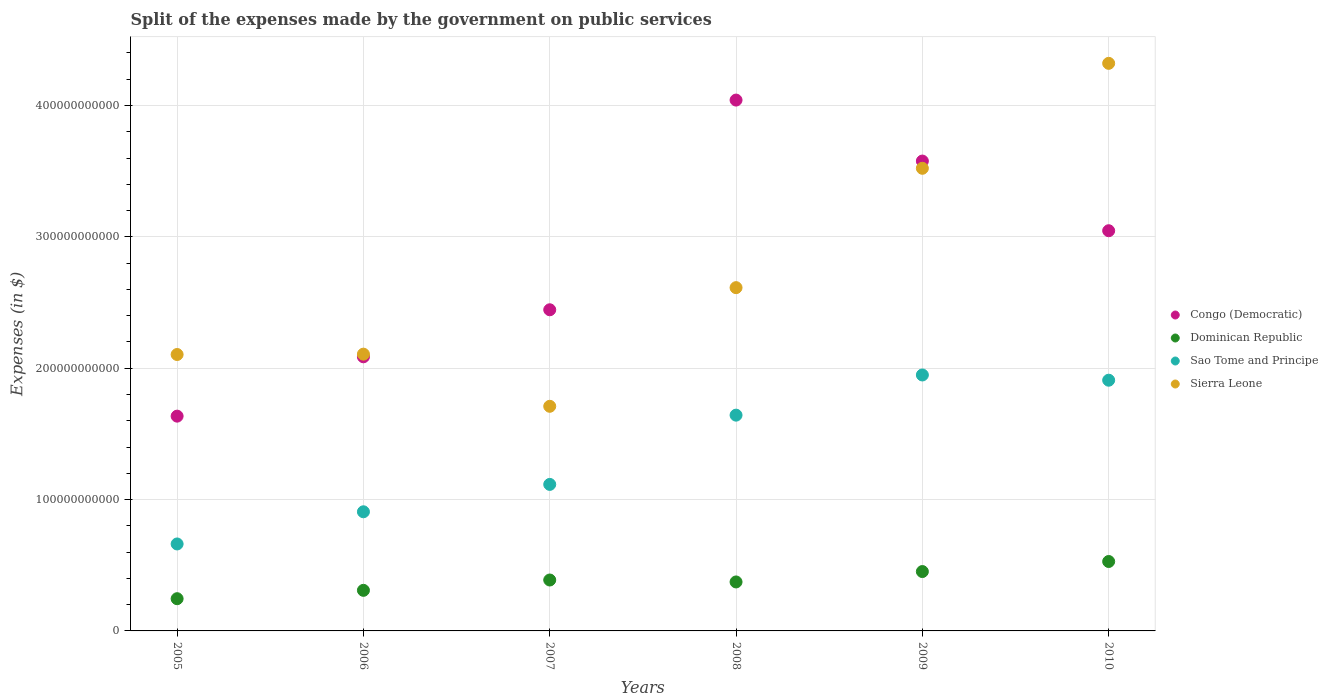How many different coloured dotlines are there?
Your answer should be very brief. 4. Is the number of dotlines equal to the number of legend labels?
Offer a terse response. Yes. What is the expenses made by the government on public services in Congo (Democratic) in 2008?
Provide a succinct answer. 4.04e+11. Across all years, what is the maximum expenses made by the government on public services in Sierra Leone?
Offer a terse response. 4.32e+11. Across all years, what is the minimum expenses made by the government on public services in Congo (Democratic)?
Offer a terse response. 1.64e+11. In which year was the expenses made by the government on public services in Dominican Republic minimum?
Make the answer very short. 2005. What is the total expenses made by the government on public services in Congo (Democratic) in the graph?
Provide a succinct answer. 1.68e+12. What is the difference between the expenses made by the government on public services in Sierra Leone in 2007 and that in 2010?
Provide a short and direct response. -2.61e+11. What is the difference between the expenses made by the government on public services in Sierra Leone in 2006 and the expenses made by the government on public services in Dominican Republic in 2007?
Your response must be concise. 1.72e+11. What is the average expenses made by the government on public services in Congo (Democratic) per year?
Your answer should be compact. 2.81e+11. In the year 2006, what is the difference between the expenses made by the government on public services in Sierra Leone and expenses made by the government on public services in Sao Tome and Principe?
Your response must be concise. 1.20e+11. In how many years, is the expenses made by the government on public services in Congo (Democratic) greater than 100000000000 $?
Provide a short and direct response. 6. What is the ratio of the expenses made by the government on public services in Dominican Republic in 2008 to that in 2009?
Provide a succinct answer. 0.82. Is the expenses made by the government on public services in Dominican Republic in 2008 less than that in 2010?
Give a very brief answer. Yes. Is the difference between the expenses made by the government on public services in Sierra Leone in 2005 and 2010 greater than the difference between the expenses made by the government on public services in Sao Tome and Principe in 2005 and 2010?
Keep it short and to the point. No. What is the difference between the highest and the second highest expenses made by the government on public services in Sao Tome and Principe?
Your answer should be compact. 3.98e+09. What is the difference between the highest and the lowest expenses made by the government on public services in Sao Tome and Principe?
Provide a short and direct response. 1.29e+11. Is the sum of the expenses made by the government on public services in Sao Tome and Principe in 2007 and 2008 greater than the maximum expenses made by the government on public services in Sierra Leone across all years?
Your response must be concise. No. Is it the case that in every year, the sum of the expenses made by the government on public services in Sao Tome and Principe and expenses made by the government on public services in Dominican Republic  is greater than the expenses made by the government on public services in Congo (Democratic)?
Your answer should be very brief. No. Is the expenses made by the government on public services in Sao Tome and Principe strictly greater than the expenses made by the government on public services in Dominican Republic over the years?
Your answer should be compact. Yes. How many years are there in the graph?
Your answer should be very brief. 6. What is the difference between two consecutive major ticks on the Y-axis?
Your response must be concise. 1.00e+11. Are the values on the major ticks of Y-axis written in scientific E-notation?
Offer a terse response. No. Does the graph contain any zero values?
Your answer should be compact. No. Does the graph contain grids?
Provide a short and direct response. Yes. What is the title of the graph?
Make the answer very short. Split of the expenses made by the government on public services. What is the label or title of the Y-axis?
Your response must be concise. Expenses (in $). What is the Expenses (in $) in Congo (Democratic) in 2005?
Offer a terse response. 1.64e+11. What is the Expenses (in $) in Dominican Republic in 2005?
Provide a short and direct response. 2.45e+1. What is the Expenses (in $) of Sao Tome and Principe in 2005?
Provide a short and direct response. 6.62e+1. What is the Expenses (in $) in Sierra Leone in 2005?
Your response must be concise. 2.10e+11. What is the Expenses (in $) in Congo (Democratic) in 2006?
Give a very brief answer. 2.09e+11. What is the Expenses (in $) in Dominican Republic in 2006?
Offer a very short reply. 3.09e+1. What is the Expenses (in $) of Sao Tome and Principe in 2006?
Offer a terse response. 9.07e+1. What is the Expenses (in $) in Sierra Leone in 2006?
Keep it short and to the point. 2.11e+11. What is the Expenses (in $) in Congo (Democratic) in 2007?
Ensure brevity in your answer.  2.44e+11. What is the Expenses (in $) in Dominican Republic in 2007?
Ensure brevity in your answer.  3.88e+1. What is the Expenses (in $) of Sao Tome and Principe in 2007?
Keep it short and to the point. 1.12e+11. What is the Expenses (in $) in Sierra Leone in 2007?
Offer a terse response. 1.71e+11. What is the Expenses (in $) of Congo (Democratic) in 2008?
Make the answer very short. 4.04e+11. What is the Expenses (in $) of Dominican Republic in 2008?
Give a very brief answer. 3.73e+1. What is the Expenses (in $) in Sao Tome and Principe in 2008?
Give a very brief answer. 1.64e+11. What is the Expenses (in $) of Sierra Leone in 2008?
Offer a terse response. 2.61e+11. What is the Expenses (in $) of Congo (Democratic) in 2009?
Offer a terse response. 3.58e+11. What is the Expenses (in $) in Dominican Republic in 2009?
Provide a succinct answer. 4.52e+1. What is the Expenses (in $) in Sao Tome and Principe in 2009?
Your response must be concise. 1.95e+11. What is the Expenses (in $) in Sierra Leone in 2009?
Your answer should be very brief. 3.52e+11. What is the Expenses (in $) of Congo (Democratic) in 2010?
Make the answer very short. 3.05e+11. What is the Expenses (in $) in Dominican Republic in 2010?
Ensure brevity in your answer.  5.28e+1. What is the Expenses (in $) in Sao Tome and Principe in 2010?
Provide a succinct answer. 1.91e+11. What is the Expenses (in $) in Sierra Leone in 2010?
Your answer should be very brief. 4.32e+11. Across all years, what is the maximum Expenses (in $) in Congo (Democratic)?
Provide a succinct answer. 4.04e+11. Across all years, what is the maximum Expenses (in $) in Dominican Republic?
Offer a very short reply. 5.28e+1. Across all years, what is the maximum Expenses (in $) in Sao Tome and Principe?
Ensure brevity in your answer.  1.95e+11. Across all years, what is the maximum Expenses (in $) of Sierra Leone?
Your answer should be very brief. 4.32e+11. Across all years, what is the minimum Expenses (in $) of Congo (Democratic)?
Keep it short and to the point. 1.64e+11. Across all years, what is the minimum Expenses (in $) of Dominican Republic?
Make the answer very short. 2.45e+1. Across all years, what is the minimum Expenses (in $) of Sao Tome and Principe?
Provide a succinct answer. 6.62e+1. Across all years, what is the minimum Expenses (in $) of Sierra Leone?
Ensure brevity in your answer.  1.71e+11. What is the total Expenses (in $) of Congo (Democratic) in the graph?
Ensure brevity in your answer.  1.68e+12. What is the total Expenses (in $) of Dominican Republic in the graph?
Offer a very short reply. 2.30e+11. What is the total Expenses (in $) in Sao Tome and Principe in the graph?
Offer a very short reply. 8.18e+11. What is the total Expenses (in $) in Sierra Leone in the graph?
Ensure brevity in your answer.  1.64e+12. What is the difference between the Expenses (in $) of Congo (Democratic) in 2005 and that in 2006?
Your answer should be compact. -4.52e+1. What is the difference between the Expenses (in $) in Dominican Republic in 2005 and that in 2006?
Offer a very short reply. -6.36e+09. What is the difference between the Expenses (in $) in Sao Tome and Principe in 2005 and that in 2006?
Keep it short and to the point. -2.45e+1. What is the difference between the Expenses (in $) in Sierra Leone in 2005 and that in 2006?
Provide a succinct answer. -2.70e+08. What is the difference between the Expenses (in $) in Congo (Democratic) in 2005 and that in 2007?
Keep it short and to the point. -8.10e+1. What is the difference between the Expenses (in $) of Dominican Republic in 2005 and that in 2007?
Give a very brief answer. -1.42e+1. What is the difference between the Expenses (in $) in Sao Tome and Principe in 2005 and that in 2007?
Your answer should be compact. -4.53e+1. What is the difference between the Expenses (in $) of Sierra Leone in 2005 and that in 2007?
Offer a very short reply. 3.94e+1. What is the difference between the Expenses (in $) of Congo (Democratic) in 2005 and that in 2008?
Provide a short and direct response. -2.41e+11. What is the difference between the Expenses (in $) in Dominican Republic in 2005 and that in 2008?
Give a very brief answer. -1.28e+1. What is the difference between the Expenses (in $) of Sao Tome and Principe in 2005 and that in 2008?
Give a very brief answer. -9.81e+1. What is the difference between the Expenses (in $) of Sierra Leone in 2005 and that in 2008?
Your response must be concise. -5.09e+1. What is the difference between the Expenses (in $) of Congo (Democratic) in 2005 and that in 2009?
Provide a succinct answer. -1.94e+11. What is the difference between the Expenses (in $) of Dominican Republic in 2005 and that in 2009?
Ensure brevity in your answer.  -2.07e+1. What is the difference between the Expenses (in $) of Sao Tome and Principe in 2005 and that in 2009?
Your response must be concise. -1.29e+11. What is the difference between the Expenses (in $) of Sierra Leone in 2005 and that in 2009?
Give a very brief answer. -1.42e+11. What is the difference between the Expenses (in $) in Congo (Democratic) in 2005 and that in 2010?
Provide a short and direct response. -1.41e+11. What is the difference between the Expenses (in $) of Dominican Republic in 2005 and that in 2010?
Offer a very short reply. -2.83e+1. What is the difference between the Expenses (in $) in Sao Tome and Principe in 2005 and that in 2010?
Offer a very short reply. -1.25e+11. What is the difference between the Expenses (in $) in Sierra Leone in 2005 and that in 2010?
Give a very brief answer. -2.22e+11. What is the difference between the Expenses (in $) in Congo (Democratic) in 2006 and that in 2007?
Keep it short and to the point. -3.58e+1. What is the difference between the Expenses (in $) of Dominican Republic in 2006 and that in 2007?
Ensure brevity in your answer.  -7.87e+09. What is the difference between the Expenses (in $) of Sao Tome and Principe in 2006 and that in 2007?
Ensure brevity in your answer.  -2.08e+1. What is the difference between the Expenses (in $) in Sierra Leone in 2006 and that in 2007?
Your response must be concise. 3.97e+1. What is the difference between the Expenses (in $) of Congo (Democratic) in 2006 and that in 2008?
Offer a very short reply. -1.95e+11. What is the difference between the Expenses (in $) of Dominican Republic in 2006 and that in 2008?
Offer a terse response. -6.39e+09. What is the difference between the Expenses (in $) in Sao Tome and Principe in 2006 and that in 2008?
Your answer should be compact. -7.36e+1. What is the difference between the Expenses (in $) of Sierra Leone in 2006 and that in 2008?
Your answer should be very brief. -5.06e+1. What is the difference between the Expenses (in $) of Congo (Democratic) in 2006 and that in 2009?
Keep it short and to the point. -1.49e+11. What is the difference between the Expenses (in $) of Dominican Republic in 2006 and that in 2009?
Give a very brief answer. -1.43e+1. What is the difference between the Expenses (in $) of Sao Tome and Principe in 2006 and that in 2009?
Provide a succinct answer. -1.04e+11. What is the difference between the Expenses (in $) of Sierra Leone in 2006 and that in 2009?
Keep it short and to the point. -1.41e+11. What is the difference between the Expenses (in $) of Congo (Democratic) in 2006 and that in 2010?
Your answer should be compact. -9.60e+1. What is the difference between the Expenses (in $) in Dominican Republic in 2006 and that in 2010?
Your answer should be very brief. -2.20e+1. What is the difference between the Expenses (in $) of Sao Tome and Principe in 2006 and that in 2010?
Your answer should be very brief. -1.00e+11. What is the difference between the Expenses (in $) in Sierra Leone in 2006 and that in 2010?
Keep it short and to the point. -2.21e+11. What is the difference between the Expenses (in $) of Congo (Democratic) in 2007 and that in 2008?
Provide a succinct answer. -1.60e+11. What is the difference between the Expenses (in $) of Dominican Republic in 2007 and that in 2008?
Ensure brevity in your answer.  1.48e+09. What is the difference between the Expenses (in $) in Sao Tome and Principe in 2007 and that in 2008?
Your answer should be very brief. -5.27e+1. What is the difference between the Expenses (in $) in Sierra Leone in 2007 and that in 2008?
Offer a terse response. -9.03e+1. What is the difference between the Expenses (in $) in Congo (Democratic) in 2007 and that in 2009?
Offer a very short reply. -1.13e+11. What is the difference between the Expenses (in $) of Dominican Republic in 2007 and that in 2009?
Your response must be concise. -6.44e+09. What is the difference between the Expenses (in $) in Sao Tome and Principe in 2007 and that in 2009?
Offer a terse response. -8.33e+1. What is the difference between the Expenses (in $) of Sierra Leone in 2007 and that in 2009?
Provide a succinct answer. -1.81e+11. What is the difference between the Expenses (in $) in Congo (Democratic) in 2007 and that in 2010?
Make the answer very short. -6.02e+1. What is the difference between the Expenses (in $) in Dominican Republic in 2007 and that in 2010?
Offer a terse response. -1.41e+1. What is the difference between the Expenses (in $) of Sao Tome and Principe in 2007 and that in 2010?
Provide a succinct answer. -7.93e+1. What is the difference between the Expenses (in $) in Sierra Leone in 2007 and that in 2010?
Your answer should be compact. -2.61e+11. What is the difference between the Expenses (in $) in Congo (Democratic) in 2008 and that in 2009?
Provide a succinct answer. 4.64e+1. What is the difference between the Expenses (in $) of Dominican Republic in 2008 and that in 2009?
Your response must be concise. -7.91e+09. What is the difference between the Expenses (in $) of Sao Tome and Principe in 2008 and that in 2009?
Offer a very short reply. -3.06e+1. What is the difference between the Expenses (in $) of Sierra Leone in 2008 and that in 2009?
Ensure brevity in your answer.  -9.09e+1. What is the difference between the Expenses (in $) of Congo (Democratic) in 2008 and that in 2010?
Give a very brief answer. 9.95e+1. What is the difference between the Expenses (in $) of Dominican Republic in 2008 and that in 2010?
Offer a terse response. -1.56e+1. What is the difference between the Expenses (in $) of Sao Tome and Principe in 2008 and that in 2010?
Provide a succinct answer. -2.66e+1. What is the difference between the Expenses (in $) of Sierra Leone in 2008 and that in 2010?
Make the answer very short. -1.71e+11. What is the difference between the Expenses (in $) in Congo (Democratic) in 2009 and that in 2010?
Your answer should be compact. 5.30e+1. What is the difference between the Expenses (in $) of Dominican Republic in 2009 and that in 2010?
Ensure brevity in your answer.  -7.65e+09. What is the difference between the Expenses (in $) of Sao Tome and Principe in 2009 and that in 2010?
Offer a very short reply. 3.98e+09. What is the difference between the Expenses (in $) of Sierra Leone in 2009 and that in 2010?
Make the answer very short. -7.99e+1. What is the difference between the Expenses (in $) of Congo (Democratic) in 2005 and the Expenses (in $) of Dominican Republic in 2006?
Offer a terse response. 1.33e+11. What is the difference between the Expenses (in $) in Congo (Democratic) in 2005 and the Expenses (in $) in Sao Tome and Principe in 2006?
Provide a short and direct response. 7.28e+1. What is the difference between the Expenses (in $) in Congo (Democratic) in 2005 and the Expenses (in $) in Sierra Leone in 2006?
Your response must be concise. -4.72e+1. What is the difference between the Expenses (in $) in Dominican Republic in 2005 and the Expenses (in $) in Sao Tome and Principe in 2006?
Your answer should be very brief. -6.62e+1. What is the difference between the Expenses (in $) of Dominican Republic in 2005 and the Expenses (in $) of Sierra Leone in 2006?
Provide a short and direct response. -1.86e+11. What is the difference between the Expenses (in $) in Sao Tome and Principe in 2005 and the Expenses (in $) in Sierra Leone in 2006?
Your answer should be very brief. -1.44e+11. What is the difference between the Expenses (in $) of Congo (Democratic) in 2005 and the Expenses (in $) of Dominican Republic in 2007?
Make the answer very short. 1.25e+11. What is the difference between the Expenses (in $) in Congo (Democratic) in 2005 and the Expenses (in $) in Sao Tome and Principe in 2007?
Your answer should be compact. 5.20e+1. What is the difference between the Expenses (in $) in Congo (Democratic) in 2005 and the Expenses (in $) in Sierra Leone in 2007?
Keep it short and to the point. -7.49e+09. What is the difference between the Expenses (in $) of Dominican Republic in 2005 and the Expenses (in $) of Sao Tome and Principe in 2007?
Provide a short and direct response. -8.70e+1. What is the difference between the Expenses (in $) in Dominican Republic in 2005 and the Expenses (in $) in Sierra Leone in 2007?
Provide a short and direct response. -1.46e+11. What is the difference between the Expenses (in $) of Sao Tome and Principe in 2005 and the Expenses (in $) of Sierra Leone in 2007?
Make the answer very short. -1.05e+11. What is the difference between the Expenses (in $) of Congo (Democratic) in 2005 and the Expenses (in $) of Dominican Republic in 2008?
Keep it short and to the point. 1.26e+11. What is the difference between the Expenses (in $) in Congo (Democratic) in 2005 and the Expenses (in $) in Sao Tome and Principe in 2008?
Keep it short and to the point. -7.53e+08. What is the difference between the Expenses (in $) in Congo (Democratic) in 2005 and the Expenses (in $) in Sierra Leone in 2008?
Make the answer very short. -9.78e+1. What is the difference between the Expenses (in $) in Dominican Republic in 2005 and the Expenses (in $) in Sao Tome and Principe in 2008?
Your answer should be very brief. -1.40e+11. What is the difference between the Expenses (in $) in Dominican Republic in 2005 and the Expenses (in $) in Sierra Leone in 2008?
Make the answer very short. -2.37e+11. What is the difference between the Expenses (in $) in Sao Tome and Principe in 2005 and the Expenses (in $) in Sierra Leone in 2008?
Your answer should be very brief. -1.95e+11. What is the difference between the Expenses (in $) in Congo (Democratic) in 2005 and the Expenses (in $) in Dominican Republic in 2009?
Provide a succinct answer. 1.18e+11. What is the difference between the Expenses (in $) in Congo (Democratic) in 2005 and the Expenses (in $) in Sao Tome and Principe in 2009?
Provide a short and direct response. -3.13e+1. What is the difference between the Expenses (in $) in Congo (Democratic) in 2005 and the Expenses (in $) in Sierra Leone in 2009?
Your answer should be compact. -1.89e+11. What is the difference between the Expenses (in $) in Dominican Republic in 2005 and the Expenses (in $) in Sao Tome and Principe in 2009?
Provide a succinct answer. -1.70e+11. What is the difference between the Expenses (in $) in Dominican Republic in 2005 and the Expenses (in $) in Sierra Leone in 2009?
Provide a short and direct response. -3.28e+11. What is the difference between the Expenses (in $) of Sao Tome and Principe in 2005 and the Expenses (in $) of Sierra Leone in 2009?
Offer a terse response. -2.86e+11. What is the difference between the Expenses (in $) in Congo (Democratic) in 2005 and the Expenses (in $) in Dominican Republic in 2010?
Your answer should be very brief. 1.11e+11. What is the difference between the Expenses (in $) in Congo (Democratic) in 2005 and the Expenses (in $) in Sao Tome and Principe in 2010?
Offer a very short reply. -2.74e+1. What is the difference between the Expenses (in $) of Congo (Democratic) in 2005 and the Expenses (in $) of Sierra Leone in 2010?
Offer a terse response. -2.69e+11. What is the difference between the Expenses (in $) in Dominican Republic in 2005 and the Expenses (in $) in Sao Tome and Principe in 2010?
Your answer should be compact. -1.66e+11. What is the difference between the Expenses (in $) in Dominican Republic in 2005 and the Expenses (in $) in Sierra Leone in 2010?
Ensure brevity in your answer.  -4.08e+11. What is the difference between the Expenses (in $) in Sao Tome and Principe in 2005 and the Expenses (in $) in Sierra Leone in 2010?
Your response must be concise. -3.66e+11. What is the difference between the Expenses (in $) of Congo (Democratic) in 2006 and the Expenses (in $) of Dominican Republic in 2007?
Provide a succinct answer. 1.70e+11. What is the difference between the Expenses (in $) of Congo (Democratic) in 2006 and the Expenses (in $) of Sao Tome and Principe in 2007?
Offer a terse response. 9.71e+1. What is the difference between the Expenses (in $) of Congo (Democratic) in 2006 and the Expenses (in $) of Sierra Leone in 2007?
Ensure brevity in your answer.  3.77e+1. What is the difference between the Expenses (in $) in Dominican Republic in 2006 and the Expenses (in $) in Sao Tome and Principe in 2007?
Provide a succinct answer. -8.06e+1. What is the difference between the Expenses (in $) in Dominican Republic in 2006 and the Expenses (in $) in Sierra Leone in 2007?
Offer a terse response. -1.40e+11. What is the difference between the Expenses (in $) of Sao Tome and Principe in 2006 and the Expenses (in $) of Sierra Leone in 2007?
Your answer should be compact. -8.03e+1. What is the difference between the Expenses (in $) of Congo (Democratic) in 2006 and the Expenses (in $) of Dominican Republic in 2008?
Provide a succinct answer. 1.71e+11. What is the difference between the Expenses (in $) of Congo (Democratic) in 2006 and the Expenses (in $) of Sao Tome and Principe in 2008?
Your answer should be very brief. 4.44e+1. What is the difference between the Expenses (in $) in Congo (Democratic) in 2006 and the Expenses (in $) in Sierra Leone in 2008?
Provide a succinct answer. -5.26e+1. What is the difference between the Expenses (in $) of Dominican Republic in 2006 and the Expenses (in $) of Sao Tome and Principe in 2008?
Your response must be concise. -1.33e+11. What is the difference between the Expenses (in $) in Dominican Republic in 2006 and the Expenses (in $) in Sierra Leone in 2008?
Offer a very short reply. -2.30e+11. What is the difference between the Expenses (in $) of Sao Tome and Principe in 2006 and the Expenses (in $) of Sierra Leone in 2008?
Keep it short and to the point. -1.71e+11. What is the difference between the Expenses (in $) of Congo (Democratic) in 2006 and the Expenses (in $) of Dominican Republic in 2009?
Give a very brief answer. 1.63e+11. What is the difference between the Expenses (in $) in Congo (Democratic) in 2006 and the Expenses (in $) in Sao Tome and Principe in 2009?
Ensure brevity in your answer.  1.38e+1. What is the difference between the Expenses (in $) of Congo (Democratic) in 2006 and the Expenses (in $) of Sierra Leone in 2009?
Offer a terse response. -1.44e+11. What is the difference between the Expenses (in $) of Dominican Republic in 2006 and the Expenses (in $) of Sao Tome and Principe in 2009?
Your answer should be compact. -1.64e+11. What is the difference between the Expenses (in $) in Dominican Republic in 2006 and the Expenses (in $) in Sierra Leone in 2009?
Your answer should be very brief. -3.21e+11. What is the difference between the Expenses (in $) of Sao Tome and Principe in 2006 and the Expenses (in $) of Sierra Leone in 2009?
Offer a very short reply. -2.61e+11. What is the difference between the Expenses (in $) in Congo (Democratic) in 2006 and the Expenses (in $) in Dominican Republic in 2010?
Give a very brief answer. 1.56e+11. What is the difference between the Expenses (in $) in Congo (Democratic) in 2006 and the Expenses (in $) in Sao Tome and Principe in 2010?
Give a very brief answer. 1.78e+1. What is the difference between the Expenses (in $) of Congo (Democratic) in 2006 and the Expenses (in $) of Sierra Leone in 2010?
Provide a short and direct response. -2.23e+11. What is the difference between the Expenses (in $) of Dominican Republic in 2006 and the Expenses (in $) of Sao Tome and Principe in 2010?
Make the answer very short. -1.60e+11. What is the difference between the Expenses (in $) of Dominican Republic in 2006 and the Expenses (in $) of Sierra Leone in 2010?
Your answer should be very brief. -4.01e+11. What is the difference between the Expenses (in $) of Sao Tome and Principe in 2006 and the Expenses (in $) of Sierra Leone in 2010?
Offer a terse response. -3.41e+11. What is the difference between the Expenses (in $) of Congo (Democratic) in 2007 and the Expenses (in $) of Dominican Republic in 2008?
Ensure brevity in your answer.  2.07e+11. What is the difference between the Expenses (in $) in Congo (Democratic) in 2007 and the Expenses (in $) in Sao Tome and Principe in 2008?
Ensure brevity in your answer.  8.02e+1. What is the difference between the Expenses (in $) in Congo (Democratic) in 2007 and the Expenses (in $) in Sierra Leone in 2008?
Keep it short and to the point. -1.68e+1. What is the difference between the Expenses (in $) in Dominican Republic in 2007 and the Expenses (in $) in Sao Tome and Principe in 2008?
Your answer should be very brief. -1.25e+11. What is the difference between the Expenses (in $) of Dominican Republic in 2007 and the Expenses (in $) of Sierra Leone in 2008?
Your answer should be very brief. -2.23e+11. What is the difference between the Expenses (in $) in Sao Tome and Principe in 2007 and the Expenses (in $) in Sierra Leone in 2008?
Your answer should be very brief. -1.50e+11. What is the difference between the Expenses (in $) in Congo (Democratic) in 2007 and the Expenses (in $) in Dominican Republic in 2009?
Keep it short and to the point. 1.99e+11. What is the difference between the Expenses (in $) of Congo (Democratic) in 2007 and the Expenses (in $) of Sao Tome and Principe in 2009?
Your response must be concise. 4.96e+1. What is the difference between the Expenses (in $) in Congo (Democratic) in 2007 and the Expenses (in $) in Sierra Leone in 2009?
Provide a short and direct response. -1.08e+11. What is the difference between the Expenses (in $) in Dominican Republic in 2007 and the Expenses (in $) in Sao Tome and Principe in 2009?
Provide a short and direct response. -1.56e+11. What is the difference between the Expenses (in $) of Dominican Republic in 2007 and the Expenses (in $) of Sierra Leone in 2009?
Keep it short and to the point. -3.13e+11. What is the difference between the Expenses (in $) in Sao Tome and Principe in 2007 and the Expenses (in $) in Sierra Leone in 2009?
Your answer should be compact. -2.41e+11. What is the difference between the Expenses (in $) of Congo (Democratic) in 2007 and the Expenses (in $) of Dominican Republic in 2010?
Provide a succinct answer. 1.92e+11. What is the difference between the Expenses (in $) of Congo (Democratic) in 2007 and the Expenses (in $) of Sao Tome and Principe in 2010?
Ensure brevity in your answer.  5.36e+1. What is the difference between the Expenses (in $) in Congo (Democratic) in 2007 and the Expenses (in $) in Sierra Leone in 2010?
Ensure brevity in your answer.  -1.88e+11. What is the difference between the Expenses (in $) in Dominican Republic in 2007 and the Expenses (in $) in Sao Tome and Principe in 2010?
Offer a very short reply. -1.52e+11. What is the difference between the Expenses (in $) of Dominican Republic in 2007 and the Expenses (in $) of Sierra Leone in 2010?
Offer a very short reply. -3.93e+11. What is the difference between the Expenses (in $) of Sao Tome and Principe in 2007 and the Expenses (in $) of Sierra Leone in 2010?
Provide a short and direct response. -3.21e+11. What is the difference between the Expenses (in $) in Congo (Democratic) in 2008 and the Expenses (in $) in Dominican Republic in 2009?
Your answer should be very brief. 3.59e+11. What is the difference between the Expenses (in $) of Congo (Democratic) in 2008 and the Expenses (in $) of Sao Tome and Principe in 2009?
Your answer should be compact. 2.09e+11. What is the difference between the Expenses (in $) of Congo (Democratic) in 2008 and the Expenses (in $) of Sierra Leone in 2009?
Your answer should be very brief. 5.19e+1. What is the difference between the Expenses (in $) in Dominican Republic in 2008 and the Expenses (in $) in Sao Tome and Principe in 2009?
Your response must be concise. -1.58e+11. What is the difference between the Expenses (in $) of Dominican Republic in 2008 and the Expenses (in $) of Sierra Leone in 2009?
Your answer should be very brief. -3.15e+11. What is the difference between the Expenses (in $) in Sao Tome and Principe in 2008 and the Expenses (in $) in Sierra Leone in 2009?
Give a very brief answer. -1.88e+11. What is the difference between the Expenses (in $) in Congo (Democratic) in 2008 and the Expenses (in $) in Dominican Republic in 2010?
Provide a short and direct response. 3.51e+11. What is the difference between the Expenses (in $) of Congo (Democratic) in 2008 and the Expenses (in $) of Sao Tome and Principe in 2010?
Ensure brevity in your answer.  2.13e+11. What is the difference between the Expenses (in $) in Congo (Democratic) in 2008 and the Expenses (in $) in Sierra Leone in 2010?
Keep it short and to the point. -2.80e+1. What is the difference between the Expenses (in $) in Dominican Republic in 2008 and the Expenses (in $) in Sao Tome and Principe in 2010?
Your response must be concise. -1.54e+11. What is the difference between the Expenses (in $) in Dominican Republic in 2008 and the Expenses (in $) in Sierra Leone in 2010?
Offer a very short reply. -3.95e+11. What is the difference between the Expenses (in $) in Sao Tome and Principe in 2008 and the Expenses (in $) in Sierra Leone in 2010?
Your response must be concise. -2.68e+11. What is the difference between the Expenses (in $) in Congo (Democratic) in 2009 and the Expenses (in $) in Dominican Republic in 2010?
Ensure brevity in your answer.  3.05e+11. What is the difference between the Expenses (in $) of Congo (Democratic) in 2009 and the Expenses (in $) of Sao Tome and Principe in 2010?
Your response must be concise. 1.67e+11. What is the difference between the Expenses (in $) of Congo (Democratic) in 2009 and the Expenses (in $) of Sierra Leone in 2010?
Provide a succinct answer. -7.44e+1. What is the difference between the Expenses (in $) in Dominican Republic in 2009 and the Expenses (in $) in Sao Tome and Principe in 2010?
Provide a succinct answer. -1.46e+11. What is the difference between the Expenses (in $) of Dominican Republic in 2009 and the Expenses (in $) of Sierra Leone in 2010?
Your answer should be compact. -3.87e+11. What is the difference between the Expenses (in $) in Sao Tome and Principe in 2009 and the Expenses (in $) in Sierra Leone in 2010?
Offer a terse response. -2.37e+11. What is the average Expenses (in $) in Congo (Democratic) per year?
Your answer should be very brief. 2.81e+11. What is the average Expenses (in $) of Dominican Republic per year?
Keep it short and to the point. 3.83e+1. What is the average Expenses (in $) in Sao Tome and Principe per year?
Provide a short and direct response. 1.36e+11. What is the average Expenses (in $) in Sierra Leone per year?
Make the answer very short. 2.73e+11. In the year 2005, what is the difference between the Expenses (in $) in Congo (Democratic) and Expenses (in $) in Dominican Republic?
Offer a very short reply. 1.39e+11. In the year 2005, what is the difference between the Expenses (in $) of Congo (Democratic) and Expenses (in $) of Sao Tome and Principe?
Your answer should be very brief. 9.73e+1. In the year 2005, what is the difference between the Expenses (in $) of Congo (Democratic) and Expenses (in $) of Sierra Leone?
Your response must be concise. -4.69e+1. In the year 2005, what is the difference between the Expenses (in $) of Dominican Republic and Expenses (in $) of Sao Tome and Principe?
Offer a terse response. -4.17e+1. In the year 2005, what is the difference between the Expenses (in $) of Dominican Republic and Expenses (in $) of Sierra Leone?
Ensure brevity in your answer.  -1.86e+11. In the year 2005, what is the difference between the Expenses (in $) in Sao Tome and Principe and Expenses (in $) in Sierra Leone?
Ensure brevity in your answer.  -1.44e+11. In the year 2006, what is the difference between the Expenses (in $) in Congo (Democratic) and Expenses (in $) in Dominican Republic?
Keep it short and to the point. 1.78e+11. In the year 2006, what is the difference between the Expenses (in $) in Congo (Democratic) and Expenses (in $) in Sao Tome and Principe?
Keep it short and to the point. 1.18e+11. In the year 2006, what is the difference between the Expenses (in $) of Congo (Democratic) and Expenses (in $) of Sierra Leone?
Provide a succinct answer. -2.01e+09. In the year 2006, what is the difference between the Expenses (in $) of Dominican Republic and Expenses (in $) of Sao Tome and Principe?
Ensure brevity in your answer.  -5.98e+1. In the year 2006, what is the difference between the Expenses (in $) in Dominican Republic and Expenses (in $) in Sierra Leone?
Offer a very short reply. -1.80e+11. In the year 2006, what is the difference between the Expenses (in $) in Sao Tome and Principe and Expenses (in $) in Sierra Leone?
Offer a terse response. -1.20e+11. In the year 2007, what is the difference between the Expenses (in $) in Congo (Democratic) and Expenses (in $) in Dominican Republic?
Provide a short and direct response. 2.06e+11. In the year 2007, what is the difference between the Expenses (in $) in Congo (Democratic) and Expenses (in $) in Sao Tome and Principe?
Your answer should be very brief. 1.33e+11. In the year 2007, what is the difference between the Expenses (in $) in Congo (Democratic) and Expenses (in $) in Sierra Leone?
Your response must be concise. 7.35e+1. In the year 2007, what is the difference between the Expenses (in $) in Dominican Republic and Expenses (in $) in Sao Tome and Principe?
Keep it short and to the point. -7.28e+1. In the year 2007, what is the difference between the Expenses (in $) in Dominican Republic and Expenses (in $) in Sierra Leone?
Your response must be concise. -1.32e+11. In the year 2007, what is the difference between the Expenses (in $) of Sao Tome and Principe and Expenses (in $) of Sierra Leone?
Offer a terse response. -5.95e+1. In the year 2008, what is the difference between the Expenses (in $) in Congo (Democratic) and Expenses (in $) in Dominican Republic?
Your answer should be very brief. 3.67e+11. In the year 2008, what is the difference between the Expenses (in $) in Congo (Democratic) and Expenses (in $) in Sao Tome and Principe?
Your answer should be very brief. 2.40e+11. In the year 2008, what is the difference between the Expenses (in $) in Congo (Democratic) and Expenses (in $) in Sierra Leone?
Your answer should be very brief. 1.43e+11. In the year 2008, what is the difference between the Expenses (in $) in Dominican Republic and Expenses (in $) in Sao Tome and Principe?
Your answer should be compact. -1.27e+11. In the year 2008, what is the difference between the Expenses (in $) in Dominican Republic and Expenses (in $) in Sierra Leone?
Offer a terse response. -2.24e+11. In the year 2008, what is the difference between the Expenses (in $) of Sao Tome and Principe and Expenses (in $) of Sierra Leone?
Offer a very short reply. -9.71e+1. In the year 2009, what is the difference between the Expenses (in $) in Congo (Democratic) and Expenses (in $) in Dominican Republic?
Your answer should be very brief. 3.12e+11. In the year 2009, what is the difference between the Expenses (in $) in Congo (Democratic) and Expenses (in $) in Sao Tome and Principe?
Your response must be concise. 1.63e+11. In the year 2009, what is the difference between the Expenses (in $) in Congo (Democratic) and Expenses (in $) in Sierra Leone?
Give a very brief answer. 5.51e+09. In the year 2009, what is the difference between the Expenses (in $) of Dominican Republic and Expenses (in $) of Sao Tome and Principe?
Ensure brevity in your answer.  -1.50e+11. In the year 2009, what is the difference between the Expenses (in $) of Dominican Republic and Expenses (in $) of Sierra Leone?
Provide a succinct answer. -3.07e+11. In the year 2009, what is the difference between the Expenses (in $) of Sao Tome and Principe and Expenses (in $) of Sierra Leone?
Your response must be concise. -1.57e+11. In the year 2010, what is the difference between the Expenses (in $) of Congo (Democratic) and Expenses (in $) of Dominican Republic?
Your answer should be compact. 2.52e+11. In the year 2010, what is the difference between the Expenses (in $) of Congo (Democratic) and Expenses (in $) of Sao Tome and Principe?
Your answer should be very brief. 1.14e+11. In the year 2010, what is the difference between the Expenses (in $) of Congo (Democratic) and Expenses (in $) of Sierra Leone?
Your answer should be compact. -1.27e+11. In the year 2010, what is the difference between the Expenses (in $) in Dominican Republic and Expenses (in $) in Sao Tome and Principe?
Provide a succinct answer. -1.38e+11. In the year 2010, what is the difference between the Expenses (in $) in Dominican Republic and Expenses (in $) in Sierra Leone?
Your answer should be compact. -3.79e+11. In the year 2010, what is the difference between the Expenses (in $) in Sao Tome and Principe and Expenses (in $) in Sierra Leone?
Your answer should be compact. -2.41e+11. What is the ratio of the Expenses (in $) in Congo (Democratic) in 2005 to that in 2006?
Provide a succinct answer. 0.78. What is the ratio of the Expenses (in $) in Dominican Republic in 2005 to that in 2006?
Make the answer very short. 0.79. What is the ratio of the Expenses (in $) of Sao Tome and Principe in 2005 to that in 2006?
Your answer should be very brief. 0.73. What is the ratio of the Expenses (in $) in Sierra Leone in 2005 to that in 2006?
Your answer should be compact. 1. What is the ratio of the Expenses (in $) of Congo (Democratic) in 2005 to that in 2007?
Provide a short and direct response. 0.67. What is the ratio of the Expenses (in $) of Dominican Republic in 2005 to that in 2007?
Ensure brevity in your answer.  0.63. What is the ratio of the Expenses (in $) in Sao Tome and Principe in 2005 to that in 2007?
Offer a very short reply. 0.59. What is the ratio of the Expenses (in $) of Sierra Leone in 2005 to that in 2007?
Keep it short and to the point. 1.23. What is the ratio of the Expenses (in $) of Congo (Democratic) in 2005 to that in 2008?
Ensure brevity in your answer.  0.4. What is the ratio of the Expenses (in $) in Dominican Republic in 2005 to that in 2008?
Keep it short and to the point. 0.66. What is the ratio of the Expenses (in $) in Sao Tome and Principe in 2005 to that in 2008?
Give a very brief answer. 0.4. What is the ratio of the Expenses (in $) in Sierra Leone in 2005 to that in 2008?
Make the answer very short. 0.81. What is the ratio of the Expenses (in $) in Congo (Democratic) in 2005 to that in 2009?
Your answer should be very brief. 0.46. What is the ratio of the Expenses (in $) in Dominican Republic in 2005 to that in 2009?
Your response must be concise. 0.54. What is the ratio of the Expenses (in $) of Sao Tome and Principe in 2005 to that in 2009?
Your answer should be compact. 0.34. What is the ratio of the Expenses (in $) of Sierra Leone in 2005 to that in 2009?
Your answer should be very brief. 0.6. What is the ratio of the Expenses (in $) of Congo (Democratic) in 2005 to that in 2010?
Make the answer very short. 0.54. What is the ratio of the Expenses (in $) in Dominican Republic in 2005 to that in 2010?
Ensure brevity in your answer.  0.46. What is the ratio of the Expenses (in $) in Sao Tome and Principe in 2005 to that in 2010?
Make the answer very short. 0.35. What is the ratio of the Expenses (in $) in Sierra Leone in 2005 to that in 2010?
Your answer should be very brief. 0.49. What is the ratio of the Expenses (in $) of Congo (Democratic) in 2006 to that in 2007?
Keep it short and to the point. 0.85. What is the ratio of the Expenses (in $) in Dominican Republic in 2006 to that in 2007?
Your response must be concise. 0.8. What is the ratio of the Expenses (in $) in Sao Tome and Principe in 2006 to that in 2007?
Give a very brief answer. 0.81. What is the ratio of the Expenses (in $) in Sierra Leone in 2006 to that in 2007?
Make the answer very short. 1.23. What is the ratio of the Expenses (in $) in Congo (Democratic) in 2006 to that in 2008?
Provide a short and direct response. 0.52. What is the ratio of the Expenses (in $) in Dominican Republic in 2006 to that in 2008?
Keep it short and to the point. 0.83. What is the ratio of the Expenses (in $) of Sao Tome and Principe in 2006 to that in 2008?
Your response must be concise. 0.55. What is the ratio of the Expenses (in $) of Sierra Leone in 2006 to that in 2008?
Provide a succinct answer. 0.81. What is the ratio of the Expenses (in $) of Congo (Democratic) in 2006 to that in 2009?
Ensure brevity in your answer.  0.58. What is the ratio of the Expenses (in $) in Dominican Republic in 2006 to that in 2009?
Make the answer very short. 0.68. What is the ratio of the Expenses (in $) of Sao Tome and Principe in 2006 to that in 2009?
Your answer should be compact. 0.47. What is the ratio of the Expenses (in $) of Sierra Leone in 2006 to that in 2009?
Ensure brevity in your answer.  0.6. What is the ratio of the Expenses (in $) in Congo (Democratic) in 2006 to that in 2010?
Provide a succinct answer. 0.69. What is the ratio of the Expenses (in $) of Dominican Republic in 2006 to that in 2010?
Your answer should be very brief. 0.58. What is the ratio of the Expenses (in $) of Sao Tome and Principe in 2006 to that in 2010?
Make the answer very short. 0.48. What is the ratio of the Expenses (in $) in Sierra Leone in 2006 to that in 2010?
Your response must be concise. 0.49. What is the ratio of the Expenses (in $) in Congo (Democratic) in 2007 to that in 2008?
Provide a succinct answer. 0.6. What is the ratio of the Expenses (in $) in Dominican Republic in 2007 to that in 2008?
Give a very brief answer. 1.04. What is the ratio of the Expenses (in $) of Sao Tome and Principe in 2007 to that in 2008?
Ensure brevity in your answer.  0.68. What is the ratio of the Expenses (in $) of Sierra Leone in 2007 to that in 2008?
Provide a succinct answer. 0.65. What is the ratio of the Expenses (in $) in Congo (Democratic) in 2007 to that in 2009?
Keep it short and to the point. 0.68. What is the ratio of the Expenses (in $) of Dominican Republic in 2007 to that in 2009?
Keep it short and to the point. 0.86. What is the ratio of the Expenses (in $) of Sao Tome and Principe in 2007 to that in 2009?
Keep it short and to the point. 0.57. What is the ratio of the Expenses (in $) in Sierra Leone in 2007 to that in 2009?
Give a very brief answer. 0.49. What is the ratio of the Expenses (in $) of Congo (Democratic) in 2007 to that in 2010?
Ensure brevity in your answer.  0.8. What is the ratio of the Expenses (in $) of Dominican Republic in 2007 to that in 2010?
Give a very brief answer. 0.73. What is the ratio of the Expenses (in $) of Sao Tome and Principe in 2007 to that in 2010?
Provide a succinct answer. 0.58. What is the ratio of the Expenses (in $) in Sierra Leone in 2007 to that in 2010?
Provide a succinct answer. 0.4. What is the ratio of the Expenses (in $) in Congo (Democratic) in 2008 to that in 2009?
Provide a succinct answer. 1.13. What is the ratio of the Expenses (in $) in Dominican Republic in 2008 to that in 2009?
Offer a very short reply. 0.82. What is the ratio of the Expenses (in $) in Sao Tome and Principe in 2008 to that in 2009?
Your answer should be very brief. 0.84. What is the ratio of the Expenses (in $) in Sierra Leone in 2008 to that in 2009?
Make the answer very short. 0.74. What is the ratio of the Expenses (in $) of Congo (Democratic) in 2008 to that in 2010?
Your response must be concise. 1.33. What is the ratio of the Expenses (in $) in Dominican Republic in 2008 to that in 2010?
Your answer should be compact. 0.71. What is the ratio of the Expenses (in $) in Sao Tome and Principe in 2008 to that in 2010?
Make the answer very short. 0.86. What is the ratio of the Expenses (in $) in Sierra Leone in 2008 to that in 2010?
Keep it short and to the point. 0.6. What is the ratio of the Expenses (in $) in Congo (Democratic) in 2009 to that in 2010?
Offer a very short reply. 1.17. What is the ratio of the Expenses (in $) in Dominican Republic in 2009 to that in 2010?
Your answer should be compact. 0.86. What is the ratio of the Expenses (in $) in Sao Tome and Principe in 2009 to that in 2010?
Give a very brief answer. 1.02. What is the ratio of the Expenses (in $) of Sierra Leone in 2009 to that in 2010?
Your answer should be very brief. 0.82. What is the difference between the highest and the second highest Expenses (in $) in Congo (Democratic)?
Your answer should be compact. 4.64e+1. What is the difference between the highest and the second highest Expenses (in $) of Dominican Republic?
Make the answer very short. 7.65e+09. What is the difference between the highest and the second highest Expenses (in $) of Sao Tome and Principe?
Make the answer very short. 3.98e+09. What is the difference between the highest and the second highest Expenses (in $) of Sierra Leone?
Ensure brevity in your answer.  7.99e+1. What is the difference between the highest and the lowest Expenses (in $) in Congo (Democratic)?
Your answer should be compact. 2.41e+11. What is the difference between the highest and the lowest Expenses (in $) of Dominican Republic?
Provide a short and direct response. 2.83e+1. What is the difference between the highest and the lowest Expenses (in $) of Sao Tome and Principe?
Offer a terse response. 1.29e+11. What is the difference between the highest and the lowest Expenses (in $) in Sierra Leone?
Offer a terse response. 2.61e+11. 